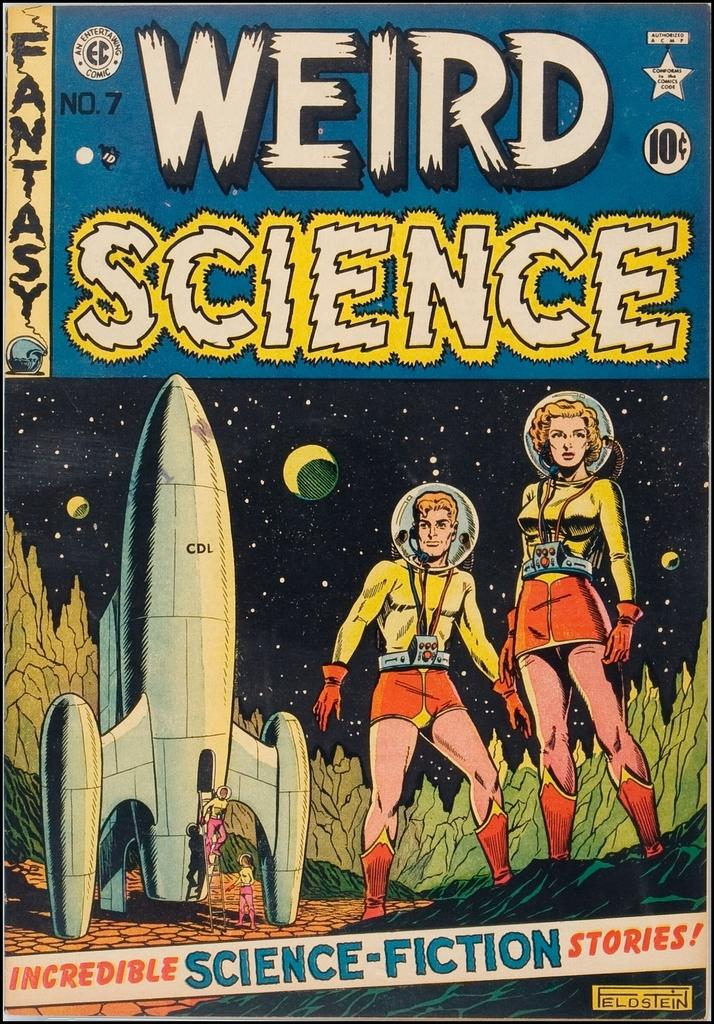<image>
Relay a brief, clear account of the picture shown. A Weird Science comic that was originally 10 Cents. 